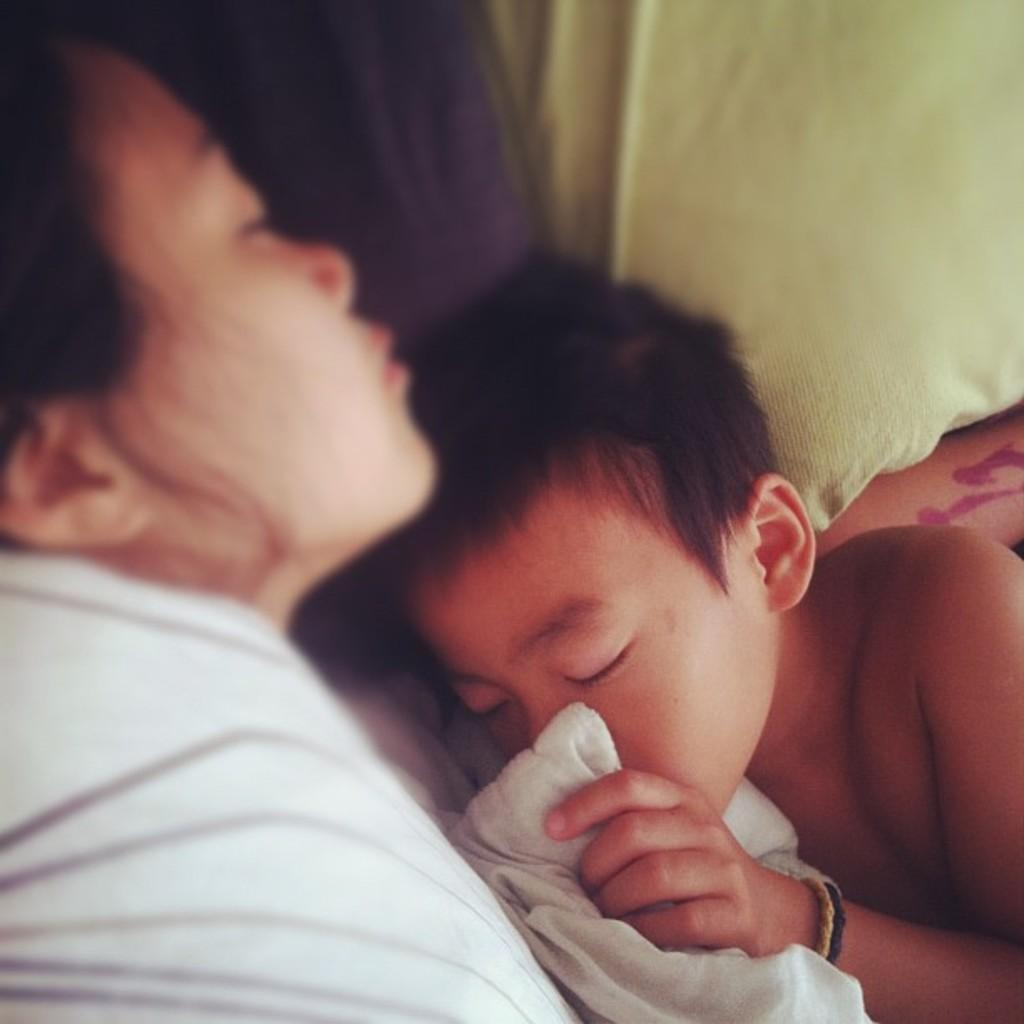Who are the people in the image? There is a woman and a boy in the image. What is the boy holding in the image? The boy is holding a cloth in the image. What type of fruit is the boy eating in the image? There is no fruit present in the image; the boy is holding a cloth. What is the woman's reaction to the pot in the image? There is no pot present in the image, so it is not possible to determine the woman's reaction to it. 